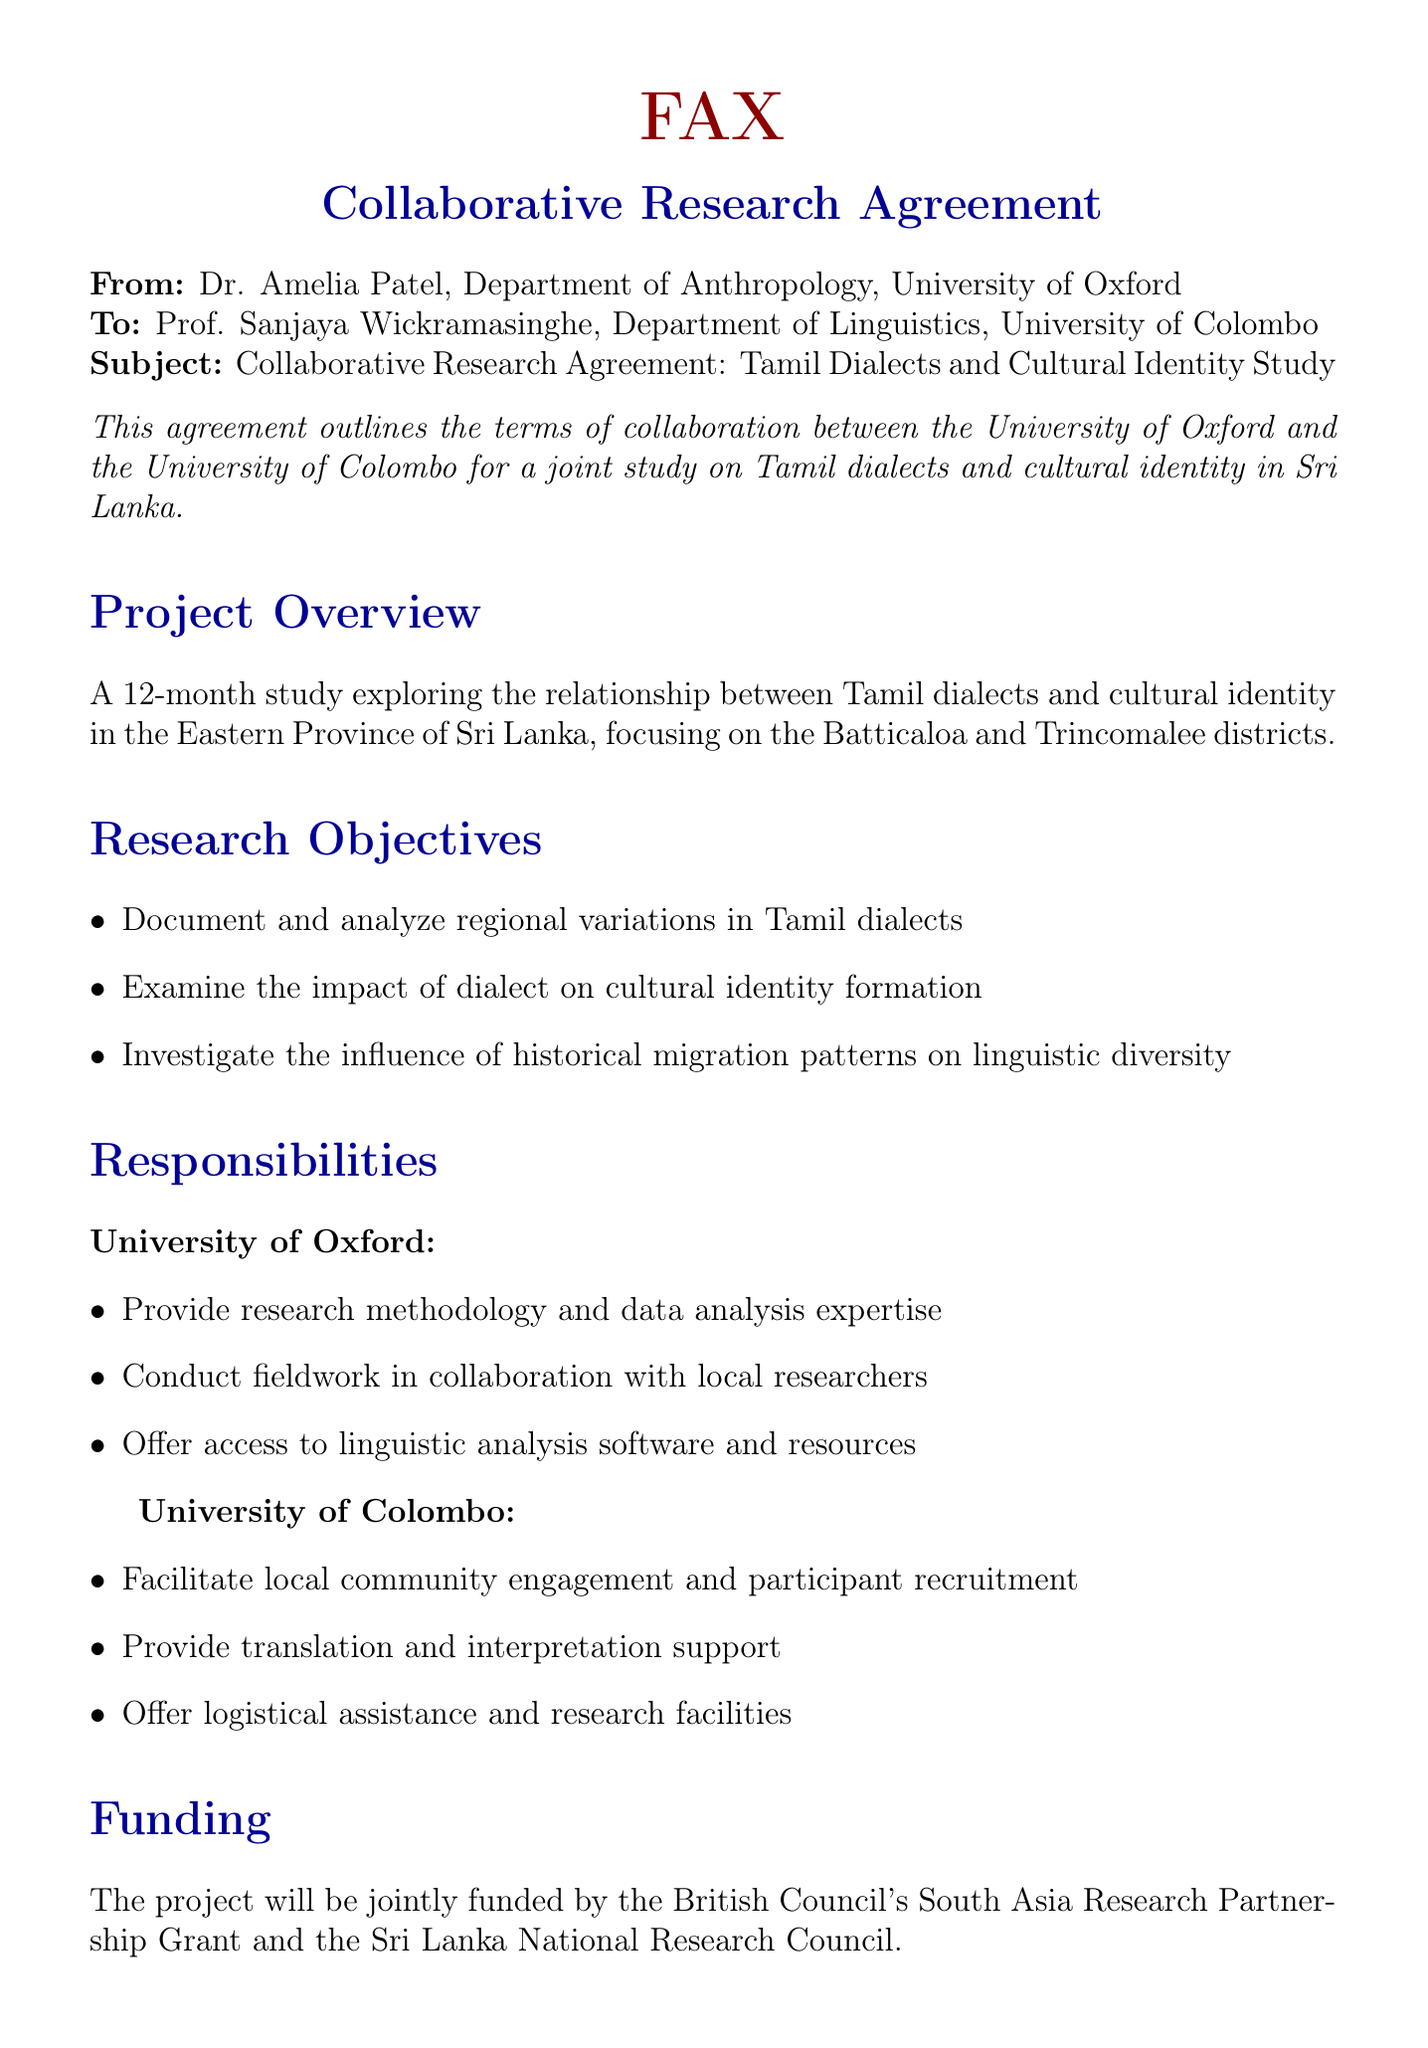What is the title of the study? The title of the study is outlined in the subject line of the fax.
Answer: Tamil Dialects and Cultural Identity Study Who is the primary contact from the University of Oxford? This is the name of the individual who sent the fax representing the University of Oxford.
Answer: Dr. Amelia Patel What is the duration of the study? The duration is specified in the project overview section of the document.
Answer: 12 months What are the two districts focused on in the study? These districts are mentioned in the project overview as areas of focus for the research.
Answer: Batticaloa and Trincomalee Which organizations are funding the project? The funding organizations are mentioned in the funding section of the document.
Answer: British Council's South Asia Research Partnership Grant and Sri Lanka National Research Council What is the project commencement date? The timeline section specifies the start date of the project.
Answer: September 1, 2023 What will happen to the data collected during the research? The data sharing section outlines the ownership and storage conditions for the collected data.
Answer: Jointly owned by both universities Who will provide logistical assistance in the research? This refers to the responsibilities assigned to one of the collaborating institutions in the document.
Answer: University of Colombo What is the purpose of the collaborative research agreement? This is explained in the introductory section of the document.
Answer: To outline the terms of collaboration for a joint study 